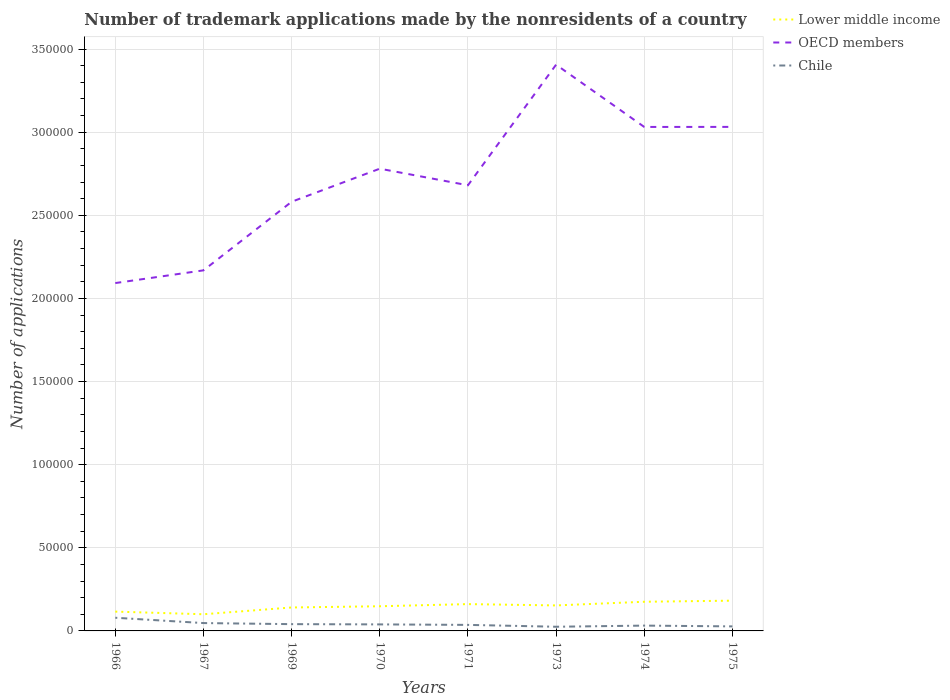How many different coloured lines are there?
Your answer should be compact. 3. Across all years, what is the maximum number of trademark applications made by the nonresidents in OECD members?
Offer a terse response. 2.09e+05. In which year was the number of trademark applications made by the nonresidents in Chile maximum?
Ensure brevity in your answer.  1973. What is the total number of trademark applications made by the nonresidents in Lower middle income in the graph?
Offer a very short reply. -735. What is the difference between the highest and the second highest number of trademark applications made by the nonresidents in Chile?
Keep it short and to the point. 5414. How many lines are there?
Your answer should be very brief. 3. Does the graph contain any zero values?
Make the answer very short. No. Where does the legend appear in the graph?
Offer a terse response. Top right. What is the title of the graph?
Offer a terse response. Number of trademark applications made by the nonresidents of a country. Does "Norway" appear as one of the legend labels in the graph?
Provide a short and direct response. No. What is the label or title of the Y-axis?
Offer a terse response. Number of applications. What is the Number of applications in Lower middle income in 1966?
Make the answer very short. 1.16e+04. What is the Number of applications in OECD members in 1966?
Provide a short and direct response. 2.09e+05. What is the Number of applications in Chile in 1966?
Your answer should be very brief. 7926. What is the Number of applications of Lower middle income in 1967?
Offer a very short reply. 1.00e+04. What is the Number of applications in OECD members in 1967?
Your answer should be very brief. 2.17e+05. What is the Number of applications in Chile in 1967?
Offer a very short reply. 4725. What is the Number of applications in Lower middle income in 1969?
Ensure brevity in your answer.  1.41e+04. What is the Number of applications in OECD members in 1969?
Give a very brief answer. 2.58e+05. What is the Number of applications of Chile in 1969?
Provide a succinct answer. 4075. What is the Number of applications in Lower middle income in 1970?
Your answer should be very brief. 1.48e+04. What is the Number of applications of OECD members in 1970?
Your response must be concise. 2.78e+05. What is the Number of applications of Chile in 1970?
Offer a terse response. 3925. What is the Number of applications of Lower middle income in 1971?
Make the answer very short. 1.61e+04. What is the Number of applications of OECD members in 1971?
Your answer should be very brief. 2.68e+05. What is the Number of applications in Chile in 1971?
Ensure brevity in your answer.  3632. What is the Number of applications in Lower middle income in 1973?
Keep it short and to the point. 1.53e+04. What is the Number of applications in OECD members in 1973?
Your response must be concise. 3.41e+05. What is the Number of applications of Chile in 1973?
Your answer should be very brief. 2512. What is the Number of applications of Lower middle income in 1974?
Provide a succinct answer. 1.75e+04. What is the Number of applications of OECD members in 1974?
Provide a succinct answer. 3.03e+05. What is the Number of applications in Chile in 1974?
Your answer should be compact. 3200. What is the Number of applications in Lower middle income in 1975?
Your answer should be very brief. 1.82e+04. What is the Number of applications in OECD members in 1975?
Your answer should be compact. 3.03e+05. What is the Number of applications in Chile in 1975?
Your answer should be compact. 2726. Across all years, what is the maximum Number of applications of Lower middle income?
Your answer should be compact. 1.82e+04. Across all years, what is the maximum Number of applications in OECD members?
Keep it short and to the point. 3.41e+05. Across all years, what is the maximum Number of applications of Chile?
Make the answer very short. 7926. Across all years, what is the minimum Number of applications in Lower middle income?
Offer a very short reply. 1.00e+04. Across all years, what is the minimum Number of applications of OECD members?
Your answer should be very brief. 2.09e+05. Across all years, what is the minimum Number of applications in Chile?
Your answer should be compact. 2512. What is the total Number of applications of Lower middle income in the graph?
Your answer should be very brief. 1.18e+05. What is the total Number of applications in OECD members in the graph?
Give a very brief answer. 2.18e+06. What is the total Number of applications in Chile in the graph?
Your response must be concise. 3.27e+04. What is the difference between the Number of applications of Lower middle income in 1966 and that in 1967?
Keep it short and to the point. 1588. What is the difference between the Number of applications in OECD members in 1966 and that in 1967?
Give a very brief answer. -7645. What is the difference between the Number of applications of Chile in 1966 and that in 1967?
Offer a very short reply. 3201. What is the difference between the Number of applications of Lower middle income in 1966 and that in 1969?
Offer a terse response. -2485. What is the difference between the Number of applications in OECD members in 1966 and that in 1969?
Ensure brevity in your answer.  -4.89e+04. What is the difference between the Number of applications in Chile in 1966 and that in 1969?
Offer a very short reply. 3851. What is the difference between the Number of applications in Lower middle income in 1966 and that in 1970?
Your response must be concise. -3220. What is the difference between the Number of applications of OECD members in 1966 and that in 1970?
Give a very brief answer. -6.88e+04. What is the difference between the Number of applications of Chile in 1966 and that in 1970?
Offer a very short reply. 4001. What is the difference between the Number of applications in Lower middle income in 1966 and that in 1971?
Your answer should be very brief. -4512. What is the difference between the Number of applications of OECD members in 1966 and that in 1971?
Your answer should be very brief. -5.88e+04. What is the difference between the Number of applications of Chile in 1966 and that in 1971?
Your answer should be very brief. 4294. What is the difference between the Number of applications of Lower middle income in 1966 and that in 1973?
Offer a very short reply. -3720. What is the difference between the Number of applications in OECD members in 1966 and that in 1973?
Your answer should be compact. -1.31e+05. What is the difference between the Number of applications of Chile in 1966 and that in 1973?
Your answer should be very brief. 5414. What is the difference between the Number of applications in Lower middle income in 1966 and that in 1974?
Provide a short and direct response. -5930. What is the difference between the Number of applications of OECD members in 1966 and that in 1974?
Your answer should be very brief. -9.39e+04. What is the difference between the Number of applications in Chile in 1966 and that in 1974?
Your answer should be very brief. 4726. What is the difference between the Number of applications in Lower middle income in 1966 and that in 1975?
Keep it short and to the point. -6582. What is the difference between the Number of applications in OECD members in 1966 and that in 1975?
Offer a very short reply. -9.39e+04. What is the difference between the Number of applications of Chile in 1966 and that in 1975?
Ensure brevity in your answer.  5200. What is the difference between the Number of applications of Lower middle income in 1967 and that in 1969?
Offer a terse response. -4073. What is the difference between the Number of applications of OECD members in 1967 and that in 1969?
Your answer should be compact. -4.13e+04. What is the difference between the Number of applications in Chile in 1967 and that in 1969?
Provide a succinct answer. 650. What is the difference between the Number of applications of Lower middle income in 1967 and that in 1970?
Your response must be concise. -4808. What is the difference between the Number of applications of OECD members in 1967 and that in 1970?
Give a very brief answer. -6.12e+04. What is the difference between the Number of applications of Chile in 1967 and that in 1970?
Offer a terse response. 800. What is the difference between the Number of applications in Lower middle income in 1967 and that in 1971?
Offer a very short reply. -6100. What is the difference between the Number of applications in OECD members in 1967 and that in 1971?
Ensure brevity in your answer.  -5.12e+04. What is the difference between the Number of applications of Chile in 1967 and that in 1971?
Keep it short and to the point. 1093. What is the difference between the Number of applications of Lower middle income in 1967 and that in 1973?
Offer a very short reply. -5308. What is the difference between the Number of applications of OECD members in 1967 and that in 1973?
Offer a very short reply. -1.24e+05. What is the difference between the Number of applications of Chile in 1967 and that in 1973?
Ensure brevity in your answer.  2213. What is the difference between the Number of applications in Lower middle income in 1967 and that in 1974?
Your response must be concise. -7518. What is the difference between the Number of applications of OECD members in 1967 and that in 1974?
Offer a terse response. -8.63e+04. What is the difference between the Number of applications of Chile in 1967 and that in 1974?
Keep it short and to the point. 1525. What is the difference between the Number of applications of Lower middle income in 1967 and that in 1975?
Provide a short and direct response. -8170. What is the difference between the Number of applications in OECD members in 1967 and that in 1975?
Your answer should be very brief. -8.63e+04. What is the difference between the Number of applications of Chile in 1967 and that in 1975?
Make the answer very short. 1999. What is the difference between the Number of applications of Lower middle income in 1969 and that in 1970?
Keep it short and to the point. -735. What is the difference between the Number of applications of OECD members in 1969 and that in 1970?
Your answer should be compact. -1.99e+04. What is the difference between the Number of applications of Chile in 1969 and that in 1970?
Make the answer very short. 150. What is the difference between the Number of applications in Lower middle income in 1969 and that in 1971?
Keep it short and to the point. -2027. What is the difference between the Number of applications of OECD members in 1969 and that in 1971?
Your answer should be very brief. -9916. What is the difference between the Number of applications in Chile in 1969 and that in 1971?
Give a very brief answer. 443. What is the difference between the Number of applications of Lower middle income in 1969 and that in 1973?
Provide a short and direct response. -1235. What is the difference between the Number of applications in OECD members in 1969 and that in 1973?
Make the answer very short. -8.25e+04. What is the difference between the Number of applications of Chile in 1969 and that in 1973?
Provide a succinct answer. 1563. What is the difference between the Number of applications of Lower middle income in 1969 and that in 1974?
Your answer should be very brief. -3445. What is the difference between the Number of applications of OECD members in 1969 and that in 1974?
Give a very brief answer. -4.50e+04. What is the difference between the Number of applications in Chile in 1969 and that in 1974?
Keep it short and to the point. 875. What is the difference between the Number of applications in Lower middle income in 1969 and that in 1975?
Offer a terse response. -4097. What is the difference between the Number of applications of OECD members in 1969 and that in 1975?
Make the answer very short. -4.50e+04. What is the difference between the Number of applications of Chile in 1969 and that in 1975?
Give a very brief answer. 1349. What is the difference between the Number of applications of Lower middle income in 1970 and that in 1971?
Offer a terse response. -1292. What is the difference between the Number of applications of OECD members in 1970 and that in 1971?
Your answer should be very brief. 9981. What is the difference between the Number of applications of Chile in 1970 and that in 1971?
Make the answer very short. 293. What is the difference between the Number of applications in Lower middle income in 1970 and that in 1973?
Ensure brevity in your answer.  -500. What is the difference between the Number of applications of OECD members in 1970 and that in 1973?
Your response must be concise. -6.26e+04. What is the difference between the Number of applications in Chile in 1970 and that in 1973?
Your answer should be very brief. 1413. What is the difference between the Number of applications of Lower middle income in 1970 and that in 1974?
Give a very brief answer. -2710. What is the difference between the Number of applications of OECD members in 1970 and that in 1974?
Offer a very short reply. -2.51e+04. What is the difference between the Number of applications in Chile in 1970 and that in 1974?
Give a very brief answer. 725. What is the difference between the Number of applications in Lower middle income in 1970 and that in 1975?
Your answer should be very brief. -3362. What is the difference between the Number of applications of OECD members in 1970 and that in 1975?
Offer a very short reply. -2.51e+04. What is the difference between the Number of applications of Chile in 1970 and that in 1975?
Make the answer very short. 1199. What is the difference between the Number of applications of Lower middle income in 1971 and that in 1973?
Ensure brevity in your answer.  792. What is the difference between the Number of applications in OECD members in 1971 and that in 1973?
Your answer should be compact. -7.25e+04. What is the difference between the Number of applications in Chile in 1971 and that in 1973?
Offer a very short reply. 1120. What is the difference between the Number of applications of Lower middle income in 1971 and that in 1974?
Keep it short and to the point. -1418. What is the difference between the Number of applications of OECD members in 1971 and that in 1974?
Offer a very short reply. -3.51e+04. What is the difference between the Number of applications of Chile in 1971 and that in 1974?
Provide a succinct answer. 432. What is the difference between the Number of applications of Lower middle income in 1971 and that in 1975?
Your answer should be compact. -2070. What is the difference between the Number of applications of OECD members in 1971 and that in 1975?
Offer a very short reply. -3.51e+04. What is the difference between the Number of applications of Chile in 1971 and that in 1975?
Provide a short and direct response. 906. What is the difference between the Number of applications of Lower middle income in 1973 and that in 1974?
Your response must be concise. -2210. What is the difference between the Number of applications of OECD members in 1973 and that in 1974?
Give a very brief answer. 3.75e+04. What is the difference between the Number of applications of Chile in 1973 and that in 1974?
Keep it short and to the point. -688. What is the difference between the Number of applications of Lower middle income in 1973 and that in 1975?
Offer a terse response. -2862. What is the difference between the Number of applications of OECD members in 1973 and that in 1975?
Your answer should be compact. 3.74e+04. What is the difference between the Number of applications of Chile in 1973 and that in 1975?
Offer a terse response. -214. What is the difference between the Number of applications in Lower middle income in 1974 and that in 1975?
Keep it short and to the point. -652. What is the difference between the Number of applications of OECD members in 1974 and that in 1975?
Make the answer very short. -33. What is the difference between the Number of applications in Chile in 1974 and that in 1975?
Make the answer very short. 474. What is the difference between the Number of applications in Lower middle income in 1966 and the Number of applications in OECD members in 1967?
Provide a short and direct response. -2.05e+05. What is the difference between the Number of applications in Lower middle income in 1966 and the Number of applications in Chile in 1967?
Your answer should be very brief. 6893. What is the difference between the Number of applications in OECD members in 1966 and the Number of applications in Chile in 1967?
Give a very brief answer. 2.05e+05. What is the difference between the Number of applications in Lower middle income in 1966 and the Number of applications in OECD members in 1969?
Your answer should be compact. -2.47e+05. What is the difference between the Number of applications of Lower middle income in 1966 and the Number of applications of Chile in 1969?
Give a very brief answer. 7543. What is the difference between the Number of applications of OECD members in 1966 and the Number of applications of Chile in 1969?
Provide a succinct answer. 2.05e+05. What is the difference between the Number of applications of Lower middle income in 1966 and the Number of applications of OECD members in 1970?
Ensure brevity in your answer.  -2.66e+05. What is the difference between the Number of applications of Lower middle income in 1966 and the Number of applications of Chile in 1970?
Offer a very short reply. 7693. What is the difference between the Number of applications of OECD members in 1966 and the Number of applications of Chile in 1970?
Offer a terse response. 2.05e+05. What is the difference between the Number of applications in Lower middle income in 1966 and the Number of applications in OECD members in 1971?
Keep it short and to the point. -2.56e+05. What is the difference between the Number of applications in Lower middle income in 1966 and the Number of applications in Chile in 1971?
Give a very brief answer. 7986. What is the difference between the Number of applications of OECD members in 1966 and the Number of applications of Chile in 1971?
Keep it short and to the point. 2.06e+05. What is the difference between the Number of applications in Lower middle income in 1966 and the Number of applications in OECD members in 1973?
Your answer should be very brief. -3.29e+05. What is the difference between the Number of applications of Lower middle income in 1966 and the Number of applications of Chile in 1973?
Your response must be concise. 9106. What is the difference between the Number of applications in OECD members in 1966 and the Number of applications in Chile in 1973?
Offer a very short reply. 2.07e+05. What is the difference between the Number of applications in Lower middle income in 1966 and the Number of applications in OECD members in 1974?
Give a very brief answer. -2.92e+05. What is the difference between the Number of applications of Lower middle income in 1966 and the Number of applications of Chile in 1974?
Give a very brief answer. 8418. What is the difference between the Number of applications in OECD members in 1966 and the Number of applications in Chile in 1974?
Provide a succinct answer. 2.06e+05. What is the difference between the Number of applications in Lower middle income in 1966 and the Number of applications in OECD members in 1975?
Offer a very short reply. -2.92e+05. What is the difference between the Number of applications of Lower middle income in 1966 and the Number of applications of Chile in 1975?
Give a very brief answer. 8892. What is the difference between the Number of applications of OECD members in 1966 and the Number of applications of Chile in 1975?
Make the answer very short. 2.07e+05. What is the difference between the Number of applications of Lower middle income in 1967 and the Number of applications of OECD members in 1969?
Offer a terse response. -2.48e+05. What is the difference between the Number of applications in Lower middle income in 1967 and the Number of applications in Chile in 1969?
Offer a very short reply. 5955. What is the difference between the Number of applications of OECD members in 1967 and the Number of applications of Chile in 1969?
Ensure brevity in your answer.  2.13e+05. What is the difference between the Number of applications in Lower middle income in 1967 and the Number of applications in OECD members in 1970?
Ensure brevity in your answer.  -2.68e+05. What is the difference between the Number of applications in Lower middle income in 1967 and the Number of applications in Chile in 1970?
Your answer should be very brief. 6105. What is the difference between the Number of applications in OECD members in 1967 and the Number of applications in Chile in 1970?
Your answer should be very brief. 2.13e+05. What is the difference between the Number of applications in Lower middle income in 1967 and the Number of applications in OECD members in 1971?
Make the answer very short. -2.58e+05. What is the difference between the Number of applications in Lower middle income in 1967 and the Number of applications in Chile in 1971?
Give a very brief answer. 6398. What is the difference between the Number of applications of OECD members in 1967 and the Number of applications of Chile in 1971?
Your answer should be very brief. 2.13e+05. What is the difference between the Number of applications of Lower middle income in 1967 and the Number of applications of OECD members in 1973?
Your answer should be very brief. -3.31e+05. What is the difference between the Number of applications in Lower middle income in 1967 and the Number of applications in Chile in 1973?
Your answer should be very brief. 7518. What is the difference between the Number of applications in OECD members in 1967 and the Number of applications in Chile in 1973?
Your response must be concise. 2.14e+05. What is the difference between the Number of applications of Lower middle income in 1967 and the Number of applications of OECD members in 1974?
Give a very brief answer. -2.93e+05. What is the difference between the Number of applications in Lower middle income in 1967 and the Number of applications in Chile in 1974?
Your answer should be compact. 6830. What is the difference between the Number of applications of OECD members in 1967 and the Number of applications of Chile in 1974?
Offer a terse response. 2.14e+05. What is the difference between the Number of applications in Lower middle income in 1967 and the Number of applications in OECD members in 1975?
Your answer should be compact. -2.93e+05. What is the difference between the Number of applications in Lower middle income in 1967 and the Number of applications in Chile in 1975?
Your answer should be compact. 7304. What is the difference between the Number of applications in OECD members in 1967 and the Number of applications in Chile in 1975?
Keep it short and to the point. 2.14e+05. What is the difference between the Number of applications in Lower middle income in 1969 and the Number of applications in OECD members in 1970?
Your answer should be very brief. -2.64e+05. What is the difference between the Number of applications in Lower middle income in 1969 and the Number of applications in Chile in 1970?
Ensure brevity in your answer.  1.02e+04. What is the difference between the Number of applications of OECD members in 1969 and the Number of applications of Chile in 1970?
Your response must be concise. 2.54e+05. What is the difference between the Number of applications in Lower middle income in 1969 and the Number of applications in OECD members in 1971?
Offer a terse response. -2.54e+05. What is the difference between the Number of applications of Lower middle income in 1969 and the Number of applications of Chile in 1971?
Provide a short and direct response. 1.05e+04. What is the difference between the Number of applications in OECD members in 1969 and the Number of applications in Chile in 1971?
Give a very brief answer. 2.55e+05. What is the difference between the Number of applications in Lower middle income in 1969 and the Number of applications in OECD members in 1973?
Give a very brief answer. -3.27e+05. What is the difference between the Number of applications of Lower middle income in 1969 and the Number of applications of Chile in 1973?
Provide a short and direct response. 1.16e+04. What is the difference between the Number of applications in OECD members in 1969 and the Number of applications in Chile in 1973?
Give a very brief answer. 2.56e+05. What is the difference between the Number of applications of Lower middle income in 1969 and the Number of applications of OECD members in 1974?
Your answer should be compact. -2.89e+05. What is the difference between the Number of applications in Lower middle income in 1969 and the Number of applications in Chile in 1974?
Make the answer very short. 1.09e+04. What is the difference between the Number of applications of OECD members in 1969 and the Number of applications of Chile in 1974?
Provide a short and direct response. 2.55e+05. What is the difference between the Number of applications of Lower middle income in 1969 and the Number of applications of OECD members in 1975?
Your answer should be very brief. -2.89e+05. What is the difference between the Number of applications of Lower middle income in 1969 and the Number of applications of Chile in 1975?
Your answer should be very brief. 1.14e+04. What is the difference between the Number of applications in OECD members in 1969 and the Number of applications in Chile in 1975?
Offer a terse response. 2.55e+05. What is the difference between the Number of applications in Lower middle income in 1970 and the Number of applications in OECD members in 1971?
Make the answer very short. -2.53e+05. What is the difference between the Number of applications of Lower middle income in 1970 and the Number of applications of Chile in 1971?
Your answer should be compact. 1.12e+04. What is the difference between the Number of applications of OECD members in 1970 and the Number of applications of Chile in 1971?
Your response must be concise. 2.74e+05. What is the difference between the Number of applications of Lower middle income in 1970 and the Number of applications of OECD members in 1973?
Make the answer very short. -3.26e+05. What is the difference between the Number of applications of Lower middle income in 1970 and the Number of applications of Chile in 1973?
Offer a terse response. 1.23e+04. What is the difference between the Number of applications of OECD members in 1970 and the Number of applications of Chile in 1973?
Provide a short and direct response. 2.76e+05. What is the difference between the Number of applications in Lower middle income in 1970 and the Number of applications in OECD members in 1974?
Offer a very short reply. -2.88e+05. What is the difference between the Number of applications in Lower middle income in 1970 and the Number of applications in Chile in 1974?
Make the answer very short. 1.16e+04. What is the difference between the Number of applications of OECD members in 1970 and the Number of applications of Chile in 1974?
Your answer should be compact. 2.75e+05. What is the difference between the Number of applications in Lower middle income in 1970 and the Number of applications in OECD members in 1975?
Offer a very short reply. -2.88e+05. What is the difference between the Number of applications in Lower middle income in 1970 and the Number of applications in Chile in 1975?
Make the answer very short. 1.21e+04. What is the difference between the Number of applications in OECD members in 1970 and the Number of applications in Chile in 1975?
Provide a succinct answer. 2.75e+05. What is the difference between the Number of applications of Lower middle income in 1971 and the Number of applications of OECD members in 1973?
Offer a very short reply. -3.24e+05. What is the difference between the Number of applications in Lower middle income in 1971 and the Number of applications in Chile in 1973?
Ensure brevity in your answer.  1.36e+04. What is the difference between the Number of applications in OECD members in 1971 and the Number of applications in Chile in 1973?
Provide a short and direct response. 2.66e+05. What is the difference between the Number of applications in Lower middle income in 1971 and the Number of applications in OECD members in 1974?
Your answer should be very brief. -2.87e+05. What is the difference between the Number of applications of Lower middle income in 1971 and the Number of applications of Chile in 1974?
Give a very brief answer. 1.29e+04. What is the difference between the Number of applications of OECD members in 1971 and the Number of applications of Chile in 1974?
Your answer should be very brief. 2.65e+05. What is the difference between the Number of applications in Lower middle income in 1971 and the Number of applications in OECD members in 1975?
Keep it short and to the point. -2.87e+05. What is the difference between the Number of applications of Lower middle income in 1971 and the Number of applications of Chile in 1975?
Give a very brief answer. 1.34e+04. What is the difference between the Number of applications in OECD members in 1971 and the Number of applications in Chile in 1975?
Provide a succinct answer. 2.65e+05. What is the difference between the Number of applications in Lower middle income in 1973 and the Number of applications in OECD members in 1974?
Give a very brief answer. -2.88e+05. What is the difference between the Number of applications of Lower middle income in 1973 and the Number of applications of Chile in 1974?
Make the answer very short. 1.21e+04. What is the difference between the Number of applications in OECD members in 1973 and the Number of applications in Chile in 1974?
Keep it short and to the point. 3.37e+05. What is the difference between the Number of applications in Lower middle income in 1973 and the Number of applications in OECD members in 1975?
Your answer should be compact. -2.88e+05. What is the difference between the Number of applications in Lower middle income in 1973 and the Number of applications in Chile in 1975?
Your answer should be compact. 1.26e+04. What is the difference between the Number of applications of OECD members in 1973 and the Number of applications of Chile in 1975?
Offer a very short reply. 3.38e+05. What is the difference between the Number of applications in Lower middle income in 1974 and the Number of applications in OECD members in 1975?
Offer a very short reply. -2.86e+05. What is the difference between the Number of applications of Lower middle income in 1974 and the Number of applications of Chile in 1975?
Offer a very short reply. 1.48e+04. What is the difference between the Number of applications of OECD members in 1974 and the Number of applications of Chile in 1975?
Your response must be concise. 3.00e+05. What is the average Number of applications of Lower middle income per year?
Your answer should be very brief. 1.47e+04. What is the average Number of applications of OECD members per year?
Your response must be concise. 2.72e+05. What is the average Number of applications in Chile per year?
Keep it short and to the point. 4090.12. In the year 1966, what is the difference between the Number of applications in Lower middle income and Number of applications in OECD members?
Your response must be concise. -1.98e+05. In the year 1966, what is the difference between the Number of applications of Lower middle income and Number of applications of Chile?
Give a very brief answer. 3692. In the year 1966, what is the difference between the Number of applications of OECD members and Number of applications of Chile?
Your answer should be compact. 2.01e+05. In the year 1967, what is the difference between the Number of applications in Lower middle income and Number of applications in OECD members?
Offer a very short reply. -2.07e+05. In the year 1967, what is the difference between the Number of applications of Lower middle income and Number of applications of Chile?
Your answer should be very brief. 5305. In the year 1967, what is the difference between the Number of applications of OECD members and Number of applications of Chile?
Make the answer very short. 2.12e+05. In the year 1969, what is the difference between the Number of applications in Lower middle income and Number of applications in OECD members?
Your answer should be compact. -2.44e+05. In the year 1969, what is the difference between the Number of applications of Lower middle income and Number of applications of Chile?
Keep it short and to the point. 1.00e+04. In the year 1969, what is the difference between the Number of applications of OECD members and Number of applications of Chile?
Make the answer very short. 2.54e+05. In the year 1970, what is the difference between the Number of applications of Lower middle income and Number of applications of OECD members?
Offer a terse response. -2.63e+05. In the year 1970, what is the difference between the Number of applications of Lower middle income and Number of applications of Chile?
Ensure brevity in your answer.  1.09e+04. In the year 1970, what is the difference between the Number of applications in OECD members and Number of applications in Chile?
Offer a very short reply. 2.74e+05. In the year 1971, what is the difference between the Number of applications of Lower middle income and Number of applications of OECD members?
Your response must be concise. -2.52e+05. In the year 1971, what is the difference between the Number of applications in Lower middle income and Number of applications in Chile?
Make the answer very short. 1.25e+04. In the year 1971, what is the difference between the Number of applications of OECD members and Number of applications of Chile?
Make the answer very short. 2.64e+05. In the year 1973, what is the difference between the Number of applications in Lower middle income and Number of applications in OECD members?
Your answer should be compact. -3.25e+05. In the year 1973, what is the difference between the Number of applications in Lower middle income and Number of applications in Chile?
Keep it short and to the point. 1.28e+04. In the year 1973, what is the difference between the Number of applications of OECD members and Number of applications of Chile?
Provide a short and direct response. 3.38e+05. In the year 1974, what is the difference between the Number of applications of Lower middle income and Number of applications of OECD members?
Make the answer very short. -2.86e+05. In the year 1974, what is the difference between the Number of applications of Lower middle income and Number of applications of Chile?
Your answer should be compact. 1.43e+04. In the year 1974, what is the difference between the Number of applications in OECD members and Number of applications in Chile?
Make the answer very short. 3.00e+05. In the year 1975, what is the difference between the Number of applications of Lower middle income and Number of applications of OECD members?
Give a very brief answer. -2.85e+05. In the year 1975, what is the difference between the Number of applications in Lower middle income and Number of applications in Chile?
Offer a terse response. 1.55e+04. In the year 1975, what is the difference between the Number of applications in OECD members and Number of applications in Chile?
Your response must be concise. 3.00e+05. What is the ratio of the Number of applications in Lower middle income in 1966 to that in 1967?
Ensure brevity in your answer.  1.16. What is the ratio of the Number of applications in OECD members in 1966 to that in 1967?
Keep it short and to the point. 0.96. What is the ratio of the Number of applications in Chile in 1966 to that in 1967?
Offer a terse response. 1.68. What is the ratio of the Number of applications in Lower middle income in 1966 to that in 1969?
Offer a very short reply. 0.82. What is the ratio of the Number of applications of OECD members in 1966 to that in 1969?
Your answer should be compact. 0.81. What is the ratio of the Number of applications of Chile in 1966 to that in 1969?
Your response must be concise. 1.95. What is the ratio of the Number of applications of Lower middle income in 1966 to that in 1970?
Ensure brevity in your answer.  0.78. What is the ratio of the Number of applications of OECD members in 1966 to that in 1970?
Give a very brief answer. 0.75. What is the ratio of the Number of applications of Chile in 1966 to that in 1970?
Keep it short and to the point. 2.02. What is the ratio of the Number of applications of Lower middle income in 1966 to that in 1971?
Keep it short and to the point. 0.72. What is the ratio of the Number of applications in OECD members in 1966 to that in 1971?
Keep it short and to the point. 0.78. What is the ratio of the Number of applications in Chile in 1966 to that in 1971?
Ensure brevity in your answer.  2.18. What is the ratio of the Number of applications in Lower middle income in 1966 to that in 1973?
Keep it short and to the point. 0.76. What is the ratio of the Number of applications of OECD members in 1966 to that in 1973?
Your answer should be very brief. 0.61. What is the ratio of the Number of applications in Chile in 1966 to that in 1973?
Your answer should be compact. 3.16. What is the ratio of the Number of applications of Lower middle income in 1966 to that in 1974?
Your response must be concise. 0.66. What is the ratio of the Number of applications in OECD members in 1966 to that in 1974?
Give a very brief answer. 0.69. What is the ratio of the Number of applications of Chile in 1966 to that in 1974?
Your response must be concise. 2.48. What is the ratio of the Number of applications of Lower middle income in 1966 to that in 1975?
Ensure brevity in your answer.  0.64. What is the ratio of the Number of applications of OECD members in 1966 to that in 1975?
Make the answer very short. 0.69. What is the ratio of the Number of applications in Chile in 1966 to that in 1975?
Your answer should be very brief. 2.91. What is the ratio of the Number of applications in Lower middle income in 1967 to that in 1969?
Offer a very short reply. 0.71. What is the ratio of the Number of applications of OECD members in 1967 to that in 1969?
Offer a terse response. 0.84. What is the ratio of the Number of applications in Chile in 1967 to that in 1969?
Ensure brevity in your answer.  1.16. What is the ratio of the Number of applications of Lower middle income in 1967 to that in 1970?
Provide a short and direct response. 0.68. What is the ratio of the Number of applications of OECD members in 1967 to that in 1970?
Provide a succinct answer. 0.78. What is the ratio of the Number of applications in Chile in 1967 to that in 1970?
Your answer should be compact. 1.2. What is the ratio of the Number of applications in Lower middle income in 1967 to that in 1971?
Your response must be concise. 0.62. What is the ratio of the Number of applications in OECD members in 1967 to that in 1971?
Your answer should be very brief. 0.81. What is the ratio of the Number of applications of Chile in 1967 to that in 1971?
Ensure brevity in your answer.  1.3. What is the ratio of the Number of applications in Lower middle income in 1967 to that in 1973?
Offer a very short reply. 0.65. What is the ratio of the Number of applications of OECD members in 1967 to that in 1973?
Give a very brief answer. 0.64. What is the ratio of the Number of applications in Chile in 1967 to that in 1973?
Provide a succinct answer. 1.88. What is the ratio of the Number of applications of Lower middle income in 1967 to that in 1974?
Your answer should be very brief. 0.57. What is the ratio of the Number of applications of OECD members in 1967 to that in 1974?
Provide a short and direct response. 0.72. What is the ratio of the Number of applications of Chile in 1967 to that in 1974?
Give a very brief answer. 1.48. What is the ratio of the Number of applications in Lower middle income in 1967 to that in 1975?
Offer a very short reply. 0.55. What is the ratio of the Number of applications of OECD members in 1967 to that in 1975?
Give a very brief answer. 0.72. What is the ratio of the Number of applications of Chile in 1967 to that in 1975?
Give a very brief answer. 1.73. What is the ratio of the Number of applications of Lower middle income in 1969 to that in 1970?
Provide a short and direct response. 0.95. What is the ratio of the Number of applications in OECD members in 1969 to that in 1970?
Your response must be concise. 0.93. What is the ratio of the Number of applications of Chile in 1969 to that in 1970?
Your answer should be compact. 1.04. What is the ratio of the Number of applications of Lower middle income in 1969 to that in 1971?
Ensure brevity in your answer.  0.87. What is the ratio of the Number of applications of Chile in 1969 to that in 1971?
Give a very brief answer. 1.12. What is the ratio of the Number of applications of Lower middle income in 1969 to that in 1973?
Make the answer very short. 0.92. What is the ratio of the Number of applications of OECD members in 1969 to that in 1973?
Offer a very short reply. 0.76. What is the ratio of the Number of applications of Chile in 1969 to that in 1973?
Offer a terse response. 1.62. What is the ratio of the Number of applications of Lower middle income in 1969 to that in 1974?
Make the answer very short. 0.8. What is the ratio of the Number of applications of OECD members in 1969 to that in 1974?
Your answer should be compact. 0.85. What is the ratio of the Number of applications of Chile in 1969 to that in 1974?
Your answer should be compact. 1.27. What is the ratio of the Number of applications of Lower middle income in 1969 to that in 1975?
Offer a very short reply. 0.77. What is the ratio of the Number of applications of OECD members in 1969 to that in 1975?
Your response must be concise. 0.85. What is the ratio of the Number of applications of Chile in 1969 to that in 1975?
Your response must be concise. 1.49. What is the ratio of the Number of applications of Lower middle income in 1970 to that in 1971?
Your response must be concise. 0.92. What is the ratio of the Number of applications in OECD members in 1970 to that in 1971?
Offer a terse response. 1.04. What is the ratio of the Number of applications in Chile in 1970 to that in 1971?
Give a very brief answer. 1.08. What is the ratio of the Number of applications of Lower middle income in 1970 to that in 1973?
Ensure brevity in your answer.  0.97. What is the ratio of the Number of applications in OECD members in 1970 to that in 1973?
Ensure brevity in your answer.  0.82. What is the ratio of the Number of applications of Chile in 1970 to that in 1973?
Give a very brief answer. 1.56. What is the ratio of the Number of applications in Lower middle income in 1970 to that in 1974?
Provide a short and direct response. 0.85. What is the ratio of the Number of applications of OECD members in 1970 to that in 1974?
Offer a very short reply. 0.92. What is the ratio of the Number of applications in Chile in 1970 to that in 1974?
Provide a succinct answer. 1.23. What is the ratio of the Number of applications in Lower middle income in 1970 to that in 1975?
Offer a terse response. 0.82. What is the ratio of the Number of applications of OECD members in 1970 to that in 1975?
Ensure brevity in your answer.  0.92. What is the ratio of the Number of applications in Chile in 1970 to that in 1975?
Your answer should be compact. 1.44. What is the ratio of the Number of applications of Lower middle income in 1971 to that in 1973?
Provide a succinct answer. 1.05. What is the ratio of the Number of applications in OECD members in 1971 to that in 1973?
Your response must be concise. 0.79. What is the ratio of the Number of applications of Chile in 1971 to that in 1973?
Provide a short and direct response. 1.45. What is the ratio of the Number of applications of Lower middle income in 1971 to that in 1974?
Make the answer very short. 0.92. What is the ratio of the Number of applications of OECD members in 1971 to that in 1974?
Offer a terse response. 0.88. What is the ratio of the Number of applications of Chile in 1971 to that in 1974?
Make the answer very short. 1.14. What is the ratio of the Number of applications of Lower middle income in 1971 to that in 1975?
Ensure brevity in your answer.  0.89. What is the ratio of the Number of applications in OECD members in 1971 to that in 1975?
Provide a short and direct response. 0.88. What is the ratio of the Number of applications in Chile in 1971 to that in 1975?
Your response must be concise. 1.33. What is the ratio of the Number of applications in Lower middle income in 1973 to that in 1974?
Ensure brevity in your answer.  0.87. What is the ratio of the Number of applications in OECD members in 1973 to that in 1974?
Your response must be concise. 1.12. What is the ratio of the Number of applications in Chile in 1973 to that in 1974?
Ensure brevity in your answer.  0.79. What is the ratio of the Number of applications in Lower middle income in 1973 to that in 1975?
Provide a short and direct response. 0.84. What is the ratio of the Number of applications of OECD members in 1973 to that in 1975?
Your answer should be very brief. 1.12. What is the ratio of the Number of applications in Chile in 1973 to that in 1975?
Your answer should be very brief. 0.92. What is the ratio of the Number of applications of Lower middle income in 1974 to that in 1975?
Offer a terse response. 0.96. What is the ratio of the Number of applications in OECD members in 1974 to that in 1975?
Provide a short and direct response. 1. What is the ratio of the Number of applications in Chile in 1974 to that in 1975?
Make the answer very short. 1.17. What is the difference between the highest and the second highest Number of applications in Lower middle income?
Ensure brevity in your answer.  652. What is the difference between the highest and the second highest Number of applications in OECD members?
Provide a succinct answer. 3.74e+04. What is the difference between the highest and the second highest Number of applications in Chile?
Ensure brevity in your answer.  3201. What is the difference between the highest and the lowest Number of applications in Lower middle income?
Keep it short and to the point. 8170. What is the difference between the highest and the lowest Number of applications of OECD members?
Provide a succinct answer. 1.31e+05. What is the difference between the highest and the lowest Number of applications of Chile?
Provide a succinct answer. 5414. 